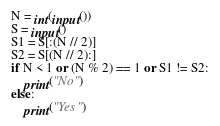<code> <loc_0><loc_0><loc_500><loc_500><_Python_>N = int(input())
S = input()
S1 = S[:(N // 2)]
S2 = S[(N // 2):]
if N < 1 or (N % 2) == 1 or S1 != S2:
    print("No")
else:
    print("Yes")</code> 